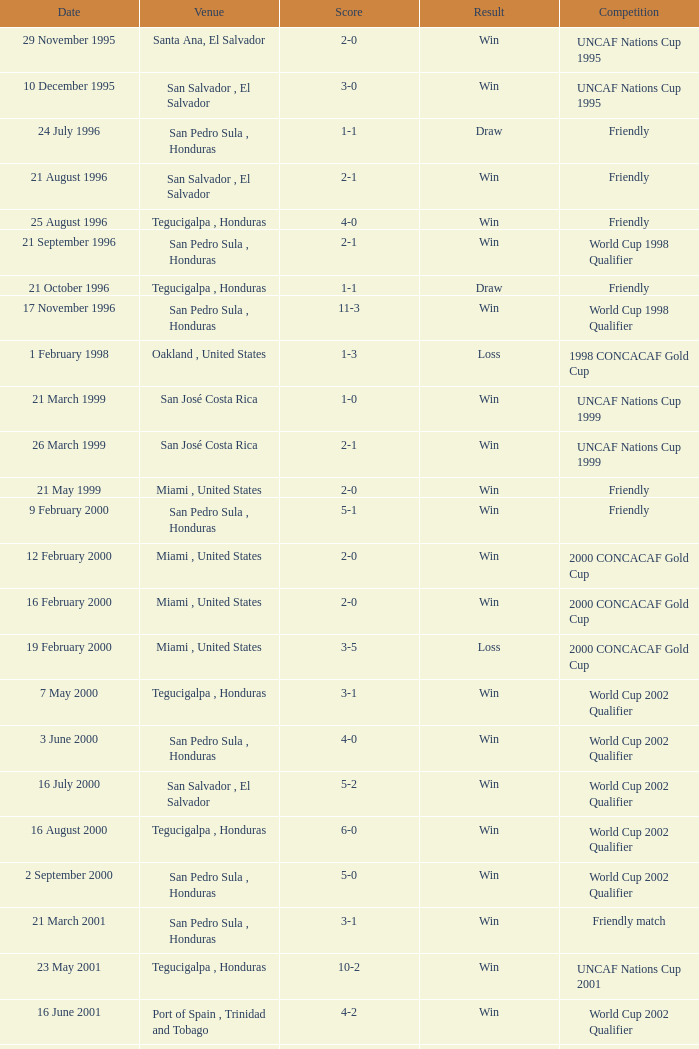State the points tally on 7th may 200 3-1. 